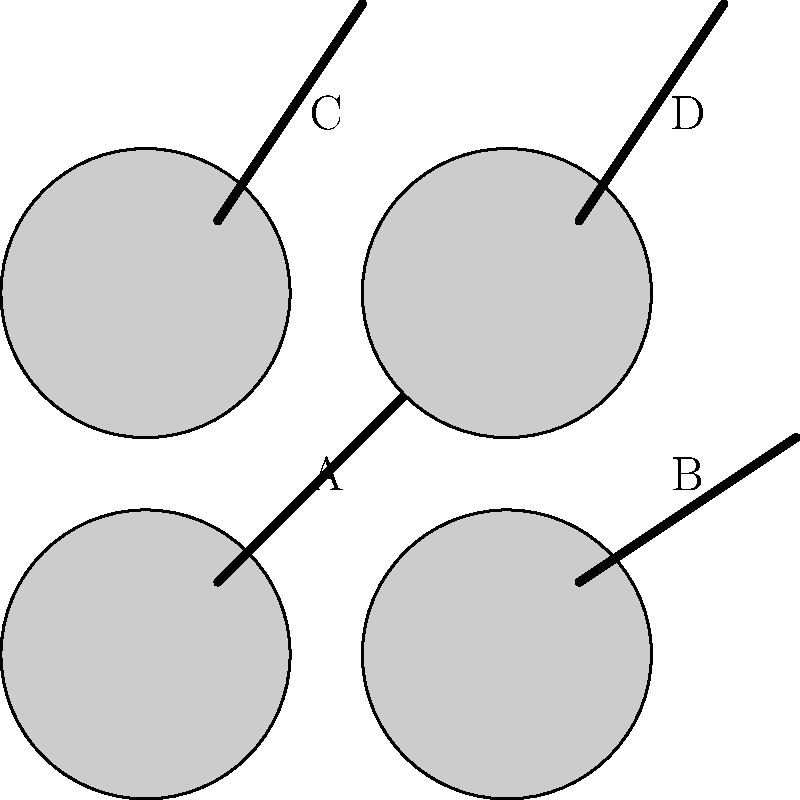Based on the partially obscured silhouettes of Alabama Crimson Tide basketball players shown above, which one is most likely to represent Collin Sexton, known for his explosive speed and relatively shorter stature compared to his teammates? To identify the silhouette most likely representing Collin Sexton, let's analyze each image:

1. Image A: Shows a tall player silhouette, which doesn't match Sexton's known shorter stature.
2. Image B: Depicts a muscular player, which could fit Sexton but doesn't emphasize his key characteristic of speed.
3. Image C: Represents a shorter player, which aligns with Sexton's physical attributes.
4. Image D: Shows an average-sized player, which doesn't particularly stand out for Sexton's characteristics.

Collin Sexton, during his time at Alabama, was known for:
- Being shorter than the average basketball player (around 6'2")
- Exceptional speed and quickness on the court
- Explosive playing style

Given these factors, the silhouette that best matches Collin Sexton's profile is Image C. It depicts a shorter player, which is consistent with Sexton's physical stature compared to his teammates. This image would best represent his quick, explosive playing style that made him stand out during his time with the Alabama Crimson Tide.
Answer: C 